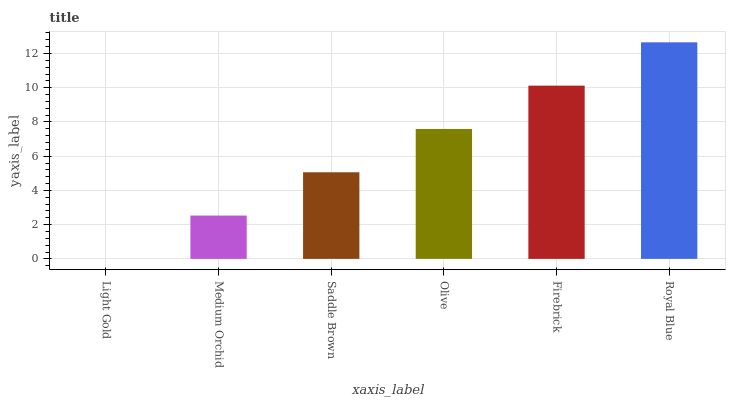Is Light Gold the minimum?
Answer yes or no. Yes. Is Royal Blue the maximum?
Answer yes or no. Yes. Is Medium Orchid the minimum?
Answer yes or no. No. Is Medium Orchid the maximum?
Answer yes or no. No. Is Medium Orchid greater than Light Gold?
Answer yes or no. Yes. Is Light Gold less than Medium Orchid?
Answer yes or no. Yes. Is Light Gold greater than Medium Orchid?
Answer yes or no. No. Is Medium Orchid less than Light Gold?
Answer yes or no. No. Is Olive the high median?
Answer yes or no. Yes. Is Saddle Brown the low median?
Answer yes or no. Yes. Is Light Gold the high median?
Answer yes or no. No. Is Royal Blue the low median?
Answer yes or no. No. 